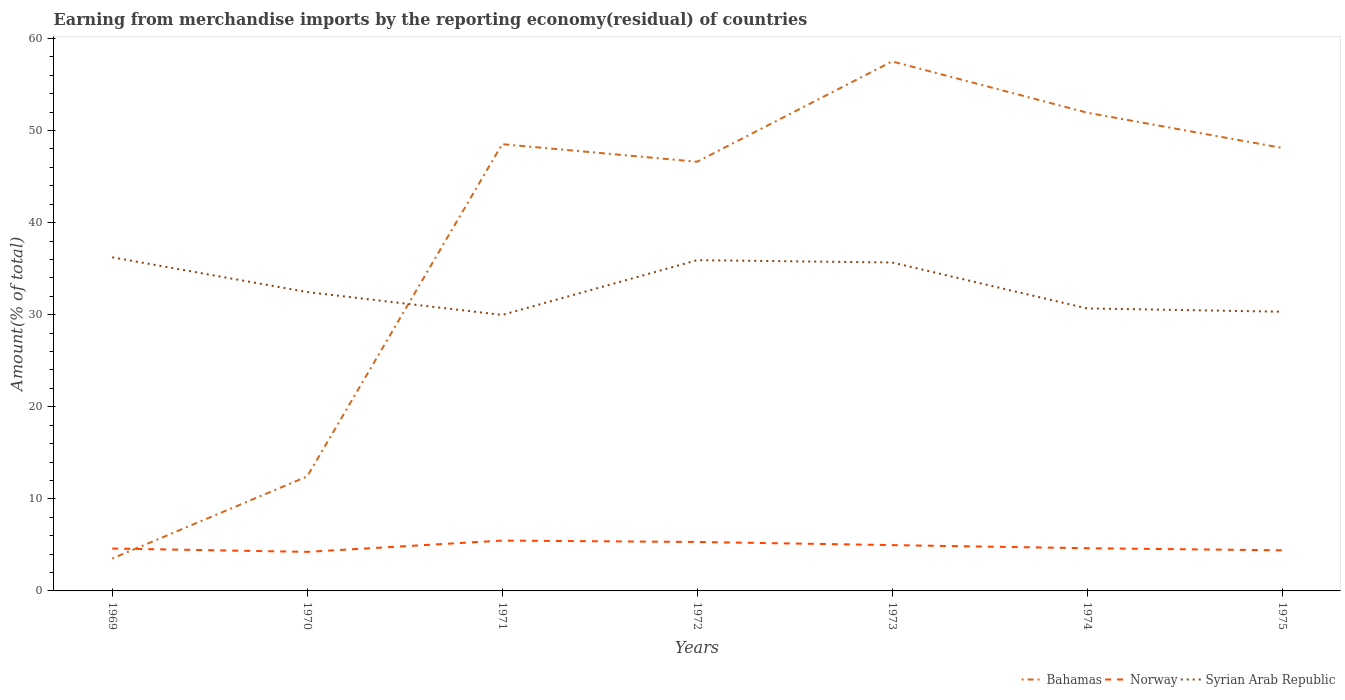How many different coloured lines are there?
Keep it short and to the point. 3. Does the line corresponding to Syrian Arab Republic intersect with the line corresponding to Norway?
Your answer should be very brief. No. Is the number of lines equal to the number of legend labels?
Ensure brevity in your answer.  Yes. Across all years, what is the maximum percentage of amount earned from merchandise imports in Norway?
Give a very brief answer. 4.24. In which year was the percentage of amount earned from merchandise imports in Syrian Arab Republic maximum?
Offer a terse response. 1971. What is the total percentage of amount earned from merchandise imports in Syrian Arab Republic in the graph?
Provide a succinct answer. 0.25. What is the difference between the highest and the second highest percentage of amount earned from merchandise imports in Syrian Arab Republic?
Make the answer very short. 6.26. How many lines are there?
Make the answer very short. 3. What is the difference between two consecutive major ticks on the Y-axis?
Your response must be concise. 10. Are the values on the major ticks of Y-axis written in scientific E-notation?
Your response must be concise. No. What is the title of the graph?
Give a very brief answer. Earning from merchandise imports by the reporting economy(residual) of countries. What is the label or title of the Y-axis?
Provide a succinct answer. Amount(% of total). What is the Amount(% of total) in Bahamas in 1969?
Your response must be concise. 3.52. What is the Amount(% of total) in Norway in 1969?
Offer a very short reply. 4.6. What is the Amount(% of total) in Syrian Arab Republic in 1969?
Give a very brief answer. 36.23. What is the Amount(% of total) of Bahamas in 1970?
Provide a short and direct response. 12.43. What is the Amount(% of total) of Norway in 1970?
Give a very brief answer. 4.24. What is the Amount(% of total) of Syrian Arab Republic in 1970?
Your response must be concise. 32.46. What is the Amount(% of total) of Bahamas in 1971?
Your answer should be very brief. 48.52. What is the Amount(% of total) in Norway in 1971?
Make the answer very short. 5.47. What is the Amount(% of total) in Syrian Arab Republic in 1971?
Your response must be concise. 29.97. What is the Amount(% of total) in Bahamas in 1972?
Your response must be concise. 46.61. What is the Amount(% of total) of Norway in 1972?
Provide a succinct answer. 5.32. What is the Amount(% of total) in Syrian Arab Republic in 1972?
Your answer should be very brief. 35.92. What is the Amount(% of total) of Bahamas in 1973?
Offer a very short reply. 57.51. What is the Amount(% of total) in Norway in 1973?
Give a very brief answer. 4.98. What is the Amount(% of total) in Syrian Arab Republic in 1973?
Ensure brevity in your answer.  35.67. What is the Amount(% of total) in Bahamas in 1974?
Ensure brevity in your answer.  51.94. What is the Amount(% of total) of Norway in 1974?
Your answer should be compact. 4.64. What is the Amount(% of total) of Syrian Arab Republic in 1974?
Your answer should be very brief. 30.68. What is the Amount(% of total) in Bahamas in 1975?
Your response must be concise. 48.11. What is the Amount(% of total) of Norway in 1975?
Keep it short and to the point. 4.41. What is the Amount(% of total) in Syrian Arab Republic in 1975?
Give a very brief answer. 30.32. Across all years, what is the maximum Amount(% of total) of Bahamas?
Provide a succinct answer. 57.51. Across all years, what is the maximum Amount(% of total) in Norway?
Keep it short and to the point. 5.47. Across all years, what is the maximum Amount(% of total) of Syrian Arab Republic?
Offer a very short reply. 36.23. Across all years, what is the minimum Amount(% of total) of Bahamas?
Your response must be concise. 3.52. Across all years, what is the minimum Amount(% of total) of Norway?
Offer a very short reply. 4.24. Across all years, what is the minimum Amount(% of total) of Syrian Arab Republic?
Give a very brief answer. 29.97. What is the total Amount(% of total) in Bahamas in the graph?
Provide a succinct answer. 268.64. What is the total Amount(% of total) of Norway in the graph?
Offer a terse response. 33.65. What is the total Amount(% of total) in Syrian Arab Republic in the graph?
Provide a short and direct response. 231.26. What is the difference between the Amount(% of total) in Bahamas in 1969 and that in 1970?
Provide a short and direct response. -8.92. What is the difference between the Amount(% of total) in Norway in 1969 and that in 1970?
Provide a short and direct response. 0.36. What is the difference between the Amount(% of total) in Syrian Arab Republic in 1969 and that in 1970?
Give a very brief answer. 3.78. What is the difference between the Amount(% of total) of Bahamas in 1969 and that in 1971?
Provide a succinct answer. -45. What is the difference between the Amount(% of total) of Norway in 1969 and that in 1971?
Your answer should be compact. -0.86. What is the difference between the Amount(% of total) of Syrian Arab Republic in 1969 and that in 1971?
Your response must be concise. 6.26. What is the difference between the Amount(% of total) of Bahamas in 1969 and that in 1972?
Provide a short and direct response. -43.09. What is the difference between the Amount(% of total) in Norway in 1969 and that in 1972?
Offer a terse response. -0.71. What is the difference between the Amount(% of total) of Syrian Arab Republic in 1969 and that in 1972?
Make the answer very short. 0.31. What is the difference between the Amount(% of total) of Bahamas in 1969 and that in 1973?
Ensure brevity in your answer.  -53.99. What is the difference between the Amount(% of total) in Norway in 1969 and that in 1973?
Give a very brief answer. -0.37. What is the difference between the Amount(% of total) in Syrian Arab Republic in 1969 and that in 1973?
Keep it short and to the point. 0.56. What is the difference between the Amount(% of total) of Bahamas in 1969 and that in 1974?
Keep it short and to the point. -48.43. What is the difference between the Amount(% of total) in Norway in 1969 and that in 1974?
Your response must be concise. -0.03. What is the difference between the Amount(% of total) in Syrian Arab Republic in 1969 and that in 1974?
Offer a very short reply. 5.55. What is the difference between the Amount(% of total) of Bahamas in 1969 and that in 1975?
Provide a succinct answer. -44.59. What is the difference between the Amount(% of total) in Norway in 1969 and that in 1975?
Keep it short and to the point. 0.19. What is the difference between the Amount(% of total) of Syrian Arab Republic in 1969 and that in 1975?
Make the answer very short. 5.91. What is the difference between the Amount(% of total) of Bahamas in 1970 and that in 1971?
Give a very brief answer. -36.09. What is the difference between the Amount(% of total) of Norway in 1970 and that in 1971?
Your response must be concise. -1.23. What is the difference between the Amount(% of total) in Syrian Arab Republic in 1970 and that in 1971?
Ensure brevity in your answer.  2.48. What is the difference between the Amount(% of total) of Bahamas in 1970 and that in 1972?
Ensure brevity in your answer.  -34.18. What is the difference between the Amount(% of total) of Norway in 1970 and that in 1972?
Make the answer very short. -1.07. What is the difference between the Amount(% of total) of Syrian Arab Republic in 1970 and that in 1972?
Offer a terse response. -3.46. What is the difference between the Amount(% of total) in Bahamas in 1970 and that in 1973?
Provide a succinct answer. -45.07. What is the difference between the Amount(% of total) in Norway in 1970 and that in 1973?
Provide a short and direct response. -0.73. What is the difference between the Amount(% of total) of Syrian Arab Republic in 1970 and that in 1973?
Keep it short and to the point. -3.21. What is the difference between the Amount(% of total) in Bahamas in 1970 and that in 1974?
Make the answer very short. -39.51. What is the difference between the Amount(% of total) in Norway in 1970 and that in 1974?
Offer a very short reply. -0.4. What is the difference between the Amount(% of total) in Syrian Arab Republic in 1970 and that in 1974?
Your answer should be compact. 1.78. What is the difference between the Amount(% of total) of Bahamas in 1970 and that in 1975?
Keep it short and to the point. -35.68. What is the difference between the Amount(% of total) of Norway in 1970 and that in 1975?
Your response must be concise. -0.17. What is the difference between the Amount(% of total) in Syrian Arab Republic in 1970 and that in 1975?
Offer a very short reply. 2.13. What is the difference between the Amount(% of total) in Bahamas in 1971 and that in 1972?
Your response must be concise. 1.91. What is the difference between the Amount(% of total) in Norway in 1971 and that in 1972?
Your response must be concise. 0.15. What is the difference between the Amount(% of total) in Syrian Arab Republic in 1971 and that in 1972?
Provide a short and direct response. -5.95. What is the difference between the Amount(% of total) of Bahamas in 1971 and that in 1973?
Your response must be concise. -8.99. What is the difference between the Amount(% of total) of Norway in 1971 and that in 1973?
Give a very brief answer. 0.49. What is the difference between the Amount(% of total) of Syrian Arab Republic in 1971 and that in 1973?
Provide a succinct answer. -5.7. What is the difference between the Amount(% of total) of Bahamas in 1971 and that in 1974?
Ensure brevity in your answer.  -3.42. What is the difference between the Amount(% of total) in Norway in 1971 and that in 1974?
Provide a short and direct response. 0.83. What is the difference between the Amount(% of total) of Syrian Arab Republic in 1971 and that in 1974?
Offer a terse response. -0.71. What is the difference between the Amount(% of total) in Bahamas in 1971 and that in 1975?
Provide a succinct answer. 0.41. What is the difference between the Amount(% of total) of Norway in 1971 and that in 1975?
Provide a short and direct response. 1.06. What is the difference between the Amount(% of total) of Syrian Arab Republic in 1971 and that in 1975?
Ensure brevity in your answer.  -0.35. What is the difference between the Amount(% of total) in Bahamas in 1972 and that in 1973?
Make the answer very short. -10.9. What is the difference between the Amount(% of total) in Norway in 1972 and that in 1973?
Provide a succinct answer. 0.34. What is the difference between the Amount(% of total) in Syrian Arab Republic in 1972 and that in 1973?
Your answer should be compact. 0.25. What is the difference between the Amount(% of total) in Bahamas in 1972 and that in 1974?
Provide a succinct answer. -5.33. What is the difference between the Amount(% of total) of Norway in 1972 and that in 1974?
Ensure brevity in your answer.  0.68. What is the difference between the Amount(% of total) of Syrian Arab Republic in 1972 and that in 1974?
Provide a short and direct response. 5.24. What is the difference between the Amount(% of total) of Bahamas in 1972 and that in 1975?
Give a very brief answer. -1.5. What is the difference between the Amount(% of total) of Norway in 1972 and that in 1975?
Offer a very short reply. 0.9. What is the difference between the Amount(% of total) of Syrian Arab Republic in 1972 and that in 1975?
Provide a short and direct response. 5.6. What is the difference between the Amount(% of total) of Bahamas in 1973 and that in 1974?
Provide a short and direct response. 5.56. What is the difference between the Amount(% of total) in Norway in 1973 and that in 1974?
Make the answer very short. 0.34. What is the difference between the Amount(% of total) in Syrian Arab Republic in 1973 and that in 1974?
Your answer should be very brief. 4.99. What is the difference between the Amount(% of total) of Bahamas in 1973 and that in 1975?
Give a very brief answer. 9.39. What is the difference between the Amount(% of total) of Norway in 1973 and that in 1975?
Make the answer very short. 0.56. What is the difference between the Amount(% of total) of Syrian Arab Republic in 1973 and that in 1975?
Provide a short and direct response. 5.35. What is the difference between the Amount(% of total) of Bahamas in 1974 and that in 1975?
Give a very brief answer. 3.83. What is the difference between the Amount(% of total) of Norway in 1974 and that in 1975?
Your response must be concise. 0.23. What is the difference between the Amount(% of total) in Syrian Arab Republic in 1974 and that in 1975?
Your answer should be very brief. 0.36. What is the difference between the Amount(% of total) of Bahamas in 1969 and the Amount(% of total) of Norway in 1970?
Your answer should be very brief. -0.72. What is the difference between the Amount(% of total) of Bahamas in 1969 and the Amount(% of total) of Syrian Arab Republic in 1970?
Your answer should be very brief. -28.94. What is the difference between the Amount(% of total) of Norway in 1969 and the Amount(% of total) of Syrian Arab Republic in 1970?
Give a very brief answer. -27.85. What is the difference between the Amount(% of total) in Bahamas in 1969 and the Amount(% of total) in Norway in 1971?
Offer a terse response. -1.95. What is the difference between the Amount(% of total) of Bahamas in 1969 and the Amount(% of total) of Syrian Arab Republic in 1971?
Your response must be concise. -26.46. What is the difference between the Amount(% of total) of Norway in 1969 and the Amount(% of total) of Syrian Arab Republic in 1971?
Give a very brief answer. -25.37. What is the difference between the Amount(% of total) of Bahamas in 1969 and the Amount(% of total) of Norway in 1972?
Provide a succinct answer. -1.8. What is the difference between the Amount(% of total) in Bahamas in 1969 and the Amount(% of total) in Syrian Arab Republic in 1972?
Your answer should be very brief. -32.4. What is the difference between the Amount(% of total) of Norway in 1969 and the Amount(% of total) of Syrian Arab Republic in 1972?
Ensure brevity in your answer.  -31.32. What is the difference between the Amount(% of total) in Bahamas in 1969 and the Amount(% of total) in Norway in 1973?
Offer a terse response. -1.46. What is the difference between the Amount(% of total) in Bahamas in 1969 and the Amount(% of total) in Syrian Arab Republic in 1973?
Your response must be concise. -32.15. What is the difference between the Amount(% of total) of Norway in 1969 and the Amount(% of total) of Syrian Arab Republic in 1973?
Give a very brief answer. -31.07. What is the difference between the Amount(% of total) in Bahamas in 1969 and the Amount(% of total) in Norway in 1974?
Offer a terse response. -1.12. What is the difference between the Amount(% of total) of Bahamas in 1969 and the Amount(% of total) of Syrian Arab Republic in 1974?
Your answer should be compact. -27.16. What is the difference between the Amount(% of total) of Norway in 1969 and the Amount(% of total) of Syrian Arab Republic in 1974?
Ensure brevity in your answer.  -26.08. What is the difference between the Amount(% of total) in Bahamas in 1969 and the Amount(% of total) in Norway in 1975?
Offer a very short reply. -0.89. What is the difference between the Amount(% of total) of Bahamas in 1969 and the Amount(% of total) of Syrian Arab Republic in 1975?
Your answer should be very brief. -26.81. What is the difference between the Amount(% of total) in Norway in 1969 and the Amount(% of total) in Syrian Arab Republic in 1975?
Your answer should be compact. -25.72. What is the difference between the Amount(% of total) of Bahamas in 1970 and the Amount(% of total) of Norway in 1971?
Make the answer very short. 6.97. What is the difference between the Amount(% of total) of Bahamas in 1970 and the Amount(% of total) of Syrian Arab Republic in 1971?
Ensure brevity in your answer.  -17.54. What is the difference between the Amount(% of total) in Norway in 1970 and the Amount(% of total) in Syrian Arab Republic in 1971?
Make the answer very short. -25.73. What is the difference between the Amount(% of total) in Bahamas in 1970 and the Amount(% of total) in Norway in 1972?
Provide a succinct answer. 7.12. What is the difference between the Amount(% of total) in Bahamas in 1970 and the Amount(% of total) in Syrian Arab Republic in 1972?
Provide a short and direct response. -23.49. What is the difference between the Amount(% of total) of Norway in 1970 and the Amount(% of total) of Syrian Arab Republic in 1972?
Make the answer very short. -31.68. What is the difference between the Amount(% of total) in Bahamas in 1970 and the Amount(% of total) in Norway in 1973?
Your response must be concise. 7.46. What is the difference between the Amount(% of total) of Bahamas in 1970 and the Amount(% of total) of Syrian Arab Republic in 1973?
Give a very brief answer. -23.24. What is the difference between the Amount(% of total) in Norway in 1970 and the Amount(% of total) in Syrian Arab Republic in 1973?
Provide a short and direct response. -31.43. What is the difference between the Amount(% of total) in Bahamas in 1970 and the Amount(% of total) in Norway in 1974?
Offer a very short reply. 7.8. What is the difference between the Amount(% of total) of Bahamas in 1970 and the Amount(% of total) of Syrian Arab Republic in 1974?
Your response must be concise. -18.25. What is the difference between the Amount(% of total) in Norway in 1970 and the Amount(% of total) in Syrian Arab Republic in 1974?
Provide a short and direct response. -26.44. What is the difference between the Amount(% of total) in Bahamas in 1970 and the Amount(% of total) in Norway in 1975?
Offer a very short reply. 8.02. What is the difference between the Amount(% of total) in Bahamas in 1970 and the Amount(% of total) in Syrian Arab Republic in 1975?
Provide a short and direct response. -17.89. What is the difference between the Amount(% of total) of Norway in 1970 and the Amount(% of total) of Syrian Arab Republic in 1975?
Your answer should be compact. -26.08. What is the difference between the Amount(% of total) of Bahamas in 1971 and the Amount(% of total) of Norway in 1972?
Your answer should be very brief. 43.2. What is the difference between the Amount(% of total) in Bahamas in 1971 and the Amount(% of total) in Syrian Arab Republic in 1972?
Give a very brief answer. 12.6. What is the difference between the Amount(% of total) in Norway in 1971 and the Amount(% of total) in Syrian Arab Republic in 1972?
Give a very brief answer. -30.45. What is the difference between the Amount(% of total) of Bahamas in 1971 and the Amount(% of total) of Norway in 1973?
Offer a terse response. 43.54. What is the difference between the Amount(% of total) in Bahamas in 1971 and the Amount(% of total) in Syrian Arab Republic in 1973?
Make the answer very short. 12.85. What is the difference between the Amount(% of total) of Norway in 1971 and the Amount(% of total) of Syrian Arab Republic in 1973?
Make the answer very short. -30.2. What is the difference between the Amount(% of total) in Bahamas in 1971 and the Amount(% of total) in Norway in 1974?
Provide a short and direct response. 43.88. What is the difference between the Amount(% of total) in Bahamas in 1971 and the Amount(% of total) in Syrian Arab Republic in 1974?
Keep it short and to the point. 17.84. What is the difference between the Amount(% of total) in Norway in 1971 and the Amount(% of total) in Syrian Arab Republic in 1974?
Your answer should be very brief. -25.21. What is the difference between the Amount(% of total) in Bahamas in 1971 and the Amount(% of total) in Norway in 1975?
Give a very brief answer. 44.11. What is the difference between the Amount(% of total) of Bahamas in 1971 and the Amount(% of total) of Syrian Arab Republic in 1975?
Offer a very short reply. 18.2. What is the difference between the Amount(% of total) of Norway in 1971 and the Amount(% of total) of Syrian Arab Republic in 1975?
Give a very brief answer. -24.86. What is the difference between the Amount(% of total) in Bahamas in 1972 and the Amount(% of total) in Norway in 1973?
Provide a short and direct response. 41.63. What is the difference between the Amount(% of total) in Bahamas in 1972 and the Amount(% of total) in Syrian Arab Republic in 1973?
Make the answer very short. 10.94. What is the difference between the Amount(% of total) in Norway in 1972 and the Amount(% of total) in Syrian Arab Republic in 1973?
Give a very brief answer. -30.35. What is the difference between the Amount(% of total) of Bahamas in 1972 and the Amount(% of total) of Norway in 1974?
Make the answer very short. 41.97. What is the difference between the Amount(% of total) in Bahamas in 1972 and the Amount(% of total) in Syrian Arab Republic in 1974?
Give a very brief answer. 15.93. What is the difference between the Amount(% of total) of Norway in 1972 and the Amount(% of total) of Syrian Arab Republic in 1974?
Make the answer very short. -25.36. What is the difference between the Amount(% of total) in Bahamas in 1972 and the Amount(% of total) in Norway in 1975?
Give a very brief answer. 42.2. What is the difference between the Amount(% of total) of Bahamas in 1972 and the Amount(% of total) of Syrian Arab Republic in 1975?
Offer a very short reply. 16.29. What is the difference between the Amount(% of total) in Norway in 1972 and the Amount(% of total) in Syrian Arab Republic in 1975?
Provide a succinct answer. -25.01. What is the difference between the Amount(% of total) in Bahamas in 1973 and the Amount(% of total) in Norway in 1974?
Your answer should be very brief. 52.87. What is the difference between the Amount(% of total) of Bahamas in 1973 and the Amount(% of total) of Syrian Arab Republic in 1974?
Provide a short and direct response. 26.83. What is the difference between the Amount(% of total) in Norway in 1973 and the Amount(% of total) in Syrian Arab Republic in 1974?
Give a very brief answer. -25.7. What is the difference between the Amount(% of total) in Bahamas in 1973 and the Amount(% of total) in Norway in 1975?
Your response must be concise. 53.09. What is the difference between the Amount(% of total) of Bahamas in 1973 and the Amount(% of total) of Syrian Arab Republic in 1975?
Make the answer very short. 27.18. What is the difference between the Amount(% of total) in Norway in 1973 and the Amount(% of total) in Syrian Arab Republic in 1975?
Your answer should be very brief. -25.35. What is the difference between the Amount(% of total) in Bahamas in 1974 and the Amount(% of total) in Norway in 1975?
Ensure brevity in your answer.  47.53. What is the difference between the Amount(% of total) in Bahamas in 1974 and the Amount(% of total) in Syrian Arab Republic in 1975?
Make the answer very short. 21.62. What is the difference between the Amount(% of total) of Norway in 1974 and the Amount(% of total) of Syrian Arab Republic in 1975?
Your answer should be compact. -25.69. What is the average Amount(% of total) of Bahamas per year?
Your response must be concise. 38.38. What is the average Amount(% of total) of Norway per year?
Make the answer very short. 4.81. What is the average Amount(% of total) in Syrian Arab Republic per year?
Offer a terse response. 33.04. In the year 1969, what is the difference between the Amount(% of total) of Bahamas and Amount(% of total) of Norway?
Your response must be concise. -1.09. In the year 1969, what is the difference between the Amount(% of total) of Bahamas and Amount(% of total) of Syrian Arab Republic?
Make the answer very short. -32.72. In the year 1969, what is the difference between the Amount(% of total) of Norway and Amount(% of total) of Syrian Arab Republic?
Your response must be concise. -31.63. In the year 1970, what is the difference between the Amount(% of total) of Bahamas and Amount(% of total) of Norway?
Give a very brief answer. 8.19. In the year 1970, what is the difference between the Amount(% of total) in Bahamas and Amount(% of total) in Syrian Arab Republic?
Ensure brevity in your answer.  -20.02. In the year 1970, what is the difference between the Amount(% of total) in Norway and Amount(% of total) in Syrian Arab Republic?
Provide a succinct answer. -28.22. In the year 1971, what is the difference between the Amount(% of total) of Bahamas and Amount(% of total) of Norway?
Make the answer very short. 43.05. In the year 1971, what is the difference between the Amount(% of total) in Bahamas and Amount(% of total) in Syrian Arab Republic?
Your answer should be compact. 18.55. In the year 1971, what is the difference between the Amount(% of total) of Norway and Amount(% of total) of Syrian Arab Republic?
Offer a terse response. -24.51. In the year 1972, what is the difference between the Amount(% of total) of Bahamas and Amount(% of total) of Norway?
Provide a succinct answer. 41.29. In the year 1972, what is the difference between the Amount(% of total) of Bahamas and Amount(% of total) of Syrian Arab Republic?
Your answer should be very brief. 10.69. In the year 1972, what is the difference between the Amount(% of total) in Norway and Amount(% of total) in Syrian Arab Republic?
Keep it short and to the point. -30.6. In the year 1973, what is the difference between the Amount(% of total) in Bahamas and Amount(% of total) in Norway?
Provide a short and direct response. 52.53. In the year 1973, what is the difference between the Amount(% of total) in Bahamas and Amount(% of total) in Syrian Arab Republic?
Offer a terse response. 21.83. In the year 1973, what is the difference between the Amount(% of total) of Norway and Amount(% of total) of Syrian Arab Republic?
Your response must be concise. -30.69. In the year 1974, what is the difference between the Amount(% of total) of Bahamas and Amount(% of total) of Norway?
Your answer should be compact. 47.31. In the year 1974, what is the difference between the Amount(% of total) of Bahamas and Amount(% of total) of Syrian Arab Republic?
Your answer should be compact. 21.26. In the year 1974, what is the difference between the Amount(% of total) of Norway and Amount(% of total) of Syrian Arab Republic?
Offer a terse response. -26.04. In the year 1975, what is the difference between the Amount(% of total) in Bahamas and Amount(% of total) in Norway?
Give a very brief answer. 43.7. In the year 1975, what is the difference between the Amount(% of total) in Bahamas and Amount(% of total) in Syrian Arab Republic?
Your answer should be compact. 17.79. In the year 1975, what is the difference between the Amount(% of total) of Norway and Amount(% of total) of Syrian Arab Republic?
Your answer should be compact. -25.91. What is the ratio of the Amount(% of total) of Bahamas in 1969 to that in 1970?
Your answer should be very brief. 0.28. What is the ratio of the Amount(% of total) of Norway in 1969 to that in 1970?
Give a very brief answer. 1.09. What is the ratio of the Amount(% of total) in Syrian Arab Republic in 1969 to that in 1970?
Offer a terse response. 1.12. What is the ratio of the Amount(% of total) of Bahamas in 1969 to that in 1971?
Your answer should be compact. 0.07. What is the ratio of the Amount(% of total) in Norway in 1969 to that in 1971?
Make the answer very short. 0.84. What is the ratio of the Amount(% of total) of Syrian Arab Republic in 1969 to that in 1971?
Ensure brevity in your answer.  1.21. What is the ratio of the Amount(% of total) in Bahamas in 1969 to that in 1972?
Keep it short and to the point. 0.08. What is the ratio of the Amount(% of total) in Norway in 1969 to that in 1972?
Offer a terse response. 0.87. What is the ratio of the Amount(% of total) of Syrian Arab Republic in 1969 to that in 1972?
Offer a very short reply. 1.01. What is the ratio of the Amount(% of total) in Bahamas in 1969 to that in 1973?
Offer a terse response. 0.06. What is the ratio of the Amount(% of total) of Norway in 1969 to that in 1973?
Keep it short and to the point. 0.93. What is the ratio of the Amount(% of total) of Syrian Arab Republic in 1969 to that in 1973?
Keep it short and to the point. 1.02. What is the ratio of the Amount(% of total) in Bahamas in 1969 to that in 1974?
Your answer should be compact. 0.07. What is the ratio of the Amount(% of total) in Syrian Arab Republic in 1969 to that in 1974?
Offer a very short reply. 1.18. What is the ratio of the Amount(% of total) of Bahamas in 1969 to that in 1975?
Your answer should be very brief. 0.07. What is the ratio of the Amount(% of total) of Norway in 1969 to that in 1975?
Give a very brief answer. 1.04. What is the ratio of the Amount(% of total) of Syrian Arab Republic in 1969 to that in 1975?
Ensure brevity in your answer.  1.19. What is the ratio of the Amount(% of total) in Bahamas in 1970 to that in 1971?
Your response must be concise. 0.26. What is the ratio of the Amount(% of total) of Norway in 1970 to that in 1971?
Offer a very short reply. 0.78. What is the ratio of the Amount(% of total) of Syrian Arab Republic in 1970 to that in 1971?
Provide a succinct answer. 1.08. What is the ratio of the Amount(% of total) of Bahamas in 1970 to that in 1972?
Your answer should be compact. 0.27. What is the ratio of the Amount(% of total) of Norway in 1970 to that in 1972?
Ensure brevity in your answer.  0.8. What is the ratio of the Amount(% of total) in Syrian Arab Republic in 1970 to that in 1972?
Provide a short and direct response. 0.9. What is the ratio of the Amount(% of total) of Bahamas in 1970 to that in 1973?
Make the answer very short. 0.22. What is the ratio of the Amount(% of total) in Norway in 1970 to that in 1973?
Ensure brevity in your answer.  0.85. What is the ratio of the Amount(% of total) of Syrian Arab Republic in 1970 to that in 1973?
Your answer should be very brief. 0.91. What is the ratio of the Amount(% of total) of Bahamas in 1970 to that in 1974?
Keep it short and to the point. 0.24. What is the ratio of the Amount(% of total) in Norway in 1970 to that in 1974?
Ensure brevity in your answer.  0.91. What is the ratio of the Amount(% of total) of Syrian Arab Republic in 1970 to that in 1974?
Your answer should be compact. 1.06. What is the ratio of the Amount(% of total) in Bahamas in 1970 to that in 1975?
Your answer should be compact. 0.26. What is the ratio of the Amount(% of total) of Norway in 1970 to that in 1975?
Your response must be concise. 0.96. What is the ratio of the Amount(% of total) in Syrian Arab Republic in 1970 to that in 1975?
Your response must be concise. 1.07. What is the ratio of the Amount(% of total) in Bahamas in 1971 to that in 1972?
Offer a very short reply. 1.04. What is the ratio of the Amount(% of total) in Norway in 1971 to that in 1972?
Ensure brevity in your answer.  1.03. What is the ratio of the Amount(% of total) of Syrian Arab Republic in 1971 to that in 1972?
Offer a very short reply. 0.83. What is the ratio of the Amount(% of total) of Bahamas in 1971 to that in 1973?
Provide a succinct answer. 0.84. What is the ratio of the Amount(% of total) in Norway in 1971 to that in 1973?
Your answer should be compact. 1.1. What is the ratio of the Amount(% of total) of Syrian Arab Republic in 1971 to that in 1973?
Make the answer very short. 0.84. What is the ratio of the Amount(% of total) in Bahamas in 1971 to that in 1974?
Your answer should be compact. 0.93. What is the ratio of the Amount(% of total) of Norway in 1971 to that in 1974?
Your answer should be compact. 1.18. What is the ratio of the Amount(% of total) of Bahamas in 1971 to that in 1975?
Offer a very short reply. 1.01. What is the ratio of the Amount(% of total) in Norway in 1971 to that in 1975?
Your answer should be compact. 1.24. What is the ratio of the Amount(% of total) in Syrian Arab Republic in 1971 to that in 1975?
Your response must be concise. 0.99. What is the ratio of the Amount(% of total) in Bahamas in 1972 to that in 1973?
Keep it short and to the point. 0.81. What is the ratio of the Amount(% of total) in Norway in 1972 to that in 1973?
Offer a terse response. 1.07. What is the ratio of the Amount(% of total) of Bahamas in 1972 to that in 1974?
Your answer should be compact. 0.9. What is the ratio of the Amount(% of total) of Norway in 1972 to that in 1974?
Keep it short and to the point. 1.15. What is the ratio of the Amount(% of total) of Syrian Arab Republic in 1972 to that in 1974?
Keep it short and to the point. 1.17. What is the ratio of the Amount(% of total) in Bahamas in 1972 to that in 1975?
Your answer should be compact. 0.97. What is the ratio of the Amount(% of total) in Norway in 1972 to that in 1975?
Offer a terse response. 1.21. What is the ratio of the Amount(% of total) in Syrian Arab Republic in 1972 to that in 1975?
Offer a terse response. 1.18. What is the ratio of the Amount(% of total) in Bahamas in 1973 to that in 1974?
Offer a terse response. 1.11. What is the ratio of the Amount(% of total) of Norway in 1973 to that in 1974?
Make the answer very short. 1.07. What is the ratio of the Amount(% of total) of Syrian Arab Republic in 1973 to that in 1974?
Make the answer very short. 1.16. What is the ratio of the Amount(% of total) of Bahamas in 1973 to that in 1975?
Provide a succinct answer. 1.2. What is the ratio of the Amount(% of total) in Norway in 1973 to that in 1975?
Provide a succinct answer. 1.13. What is the ratio of the Amount(% of total) of Syrian Arab Republic in 1973 to that in 1975?
Your answer should be very brief. 1.18. What is the ratio of the Amount(% of total) in Bahamas in 1974 to that in 1975?
Offer a terse response. 1.08. What is the ratio of the Amount(% of total) in Norway in 1974 to that in 1975?
Offer a terse response. 1.05. What is the ratio of the Amount(% of total) of Syrian Arab Republic in 1974 to that in 1975?
Your answer should be very brief. 1.01. What is the difference between the highest and the second highest Amount(% of total) in Bahamas?
Ensure brevity in your answer.  5.56. What is the difference between the highest and the second highest Amount(% of total) of Norway?
Provide a short and direct response. 0.15. What is the difference between the highest and the second highest Amount(% of total) in Syrian Arab Republic?
Offer a terse response. 0.31. What is the difference between the highest and the lowest Amount(% of total) in Bahamas?
Keep it short and to the point. 53.99. What is the difference between the highest and the lowest Amount(% of total) of Norway?
Your answer should be compact. 1.23. What is the difference between the highest and the lowest Amount(% of total) of Syrian Arab Republic?
Your response must be concise. 6.26. 